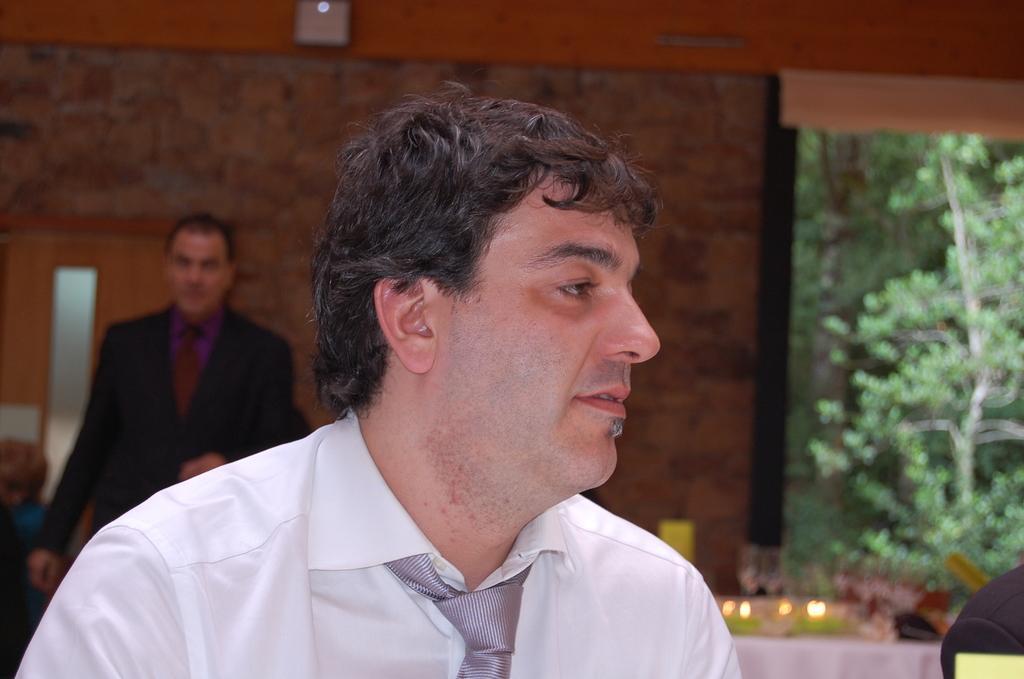Can you describe this image briefly? In this image there is a man who is wearing the white shirt and a tie. In the background there is another man standing in front of the wall. On the left side there is a door. On the right side there is a tree in the background. On the right side bottom there is a table on which there are lights. 